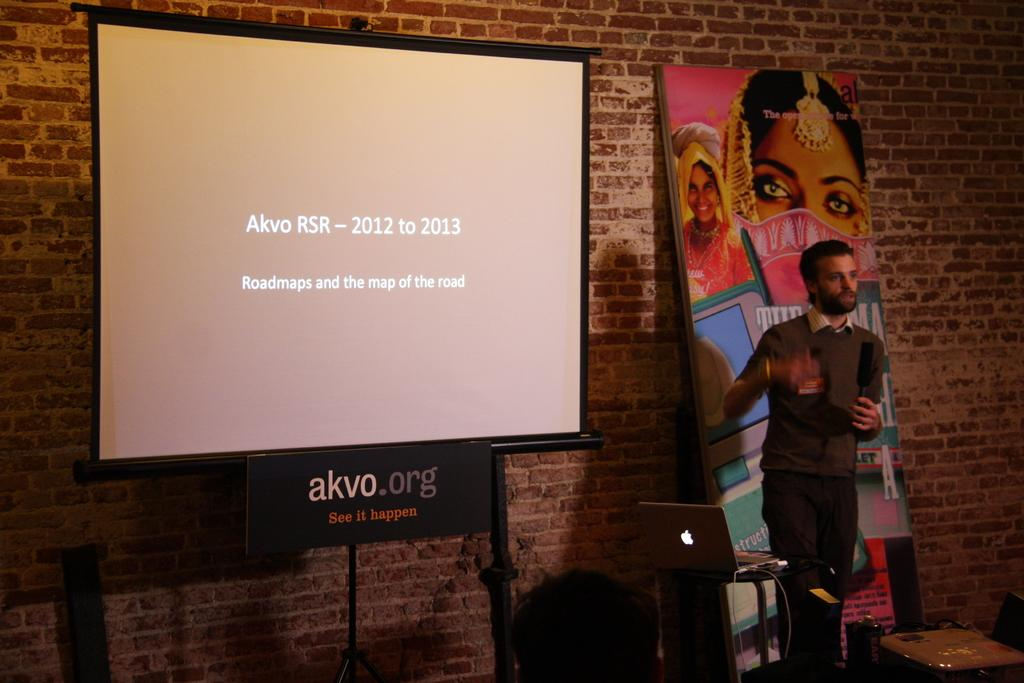What is the person in the image doing? The person is speaking into a microphone in the image. What electronic device is visible in the image? There is a laptop in the image. What is the purpose of the projector screen in the image? The projector screen is likely used for displaying visuals during the presentation. Can you describe any other objects in the image? There are additional objects in the image, but their specific details are not mentioned in the provided facts. What type of seed is being planted in the image? There is no seed or planting activity present in the image. How many letters are visible on the cork in the image? There is no cork or letters present in the image. 